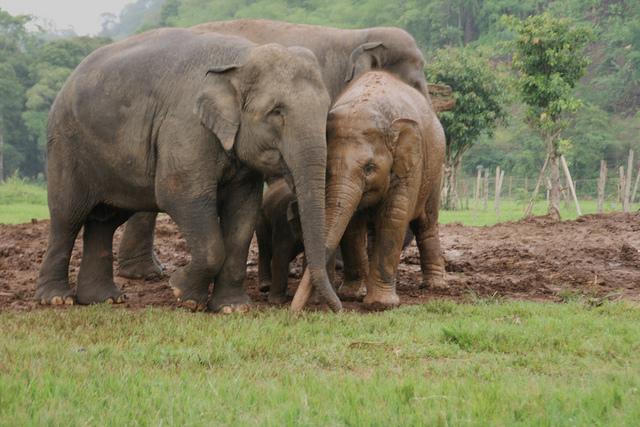Are these elephants in the wild?
Concise answer only. Yes. How many babies are in the picture?
Be succinct. 1. How many animals are there?
Short answer required. 3. Is this the elephant's natural habitat?
Short answer required. No. Are the animals African elephants?
Short answer required. Yes. Are the animals standing in grass?
Keep it brief. No. 